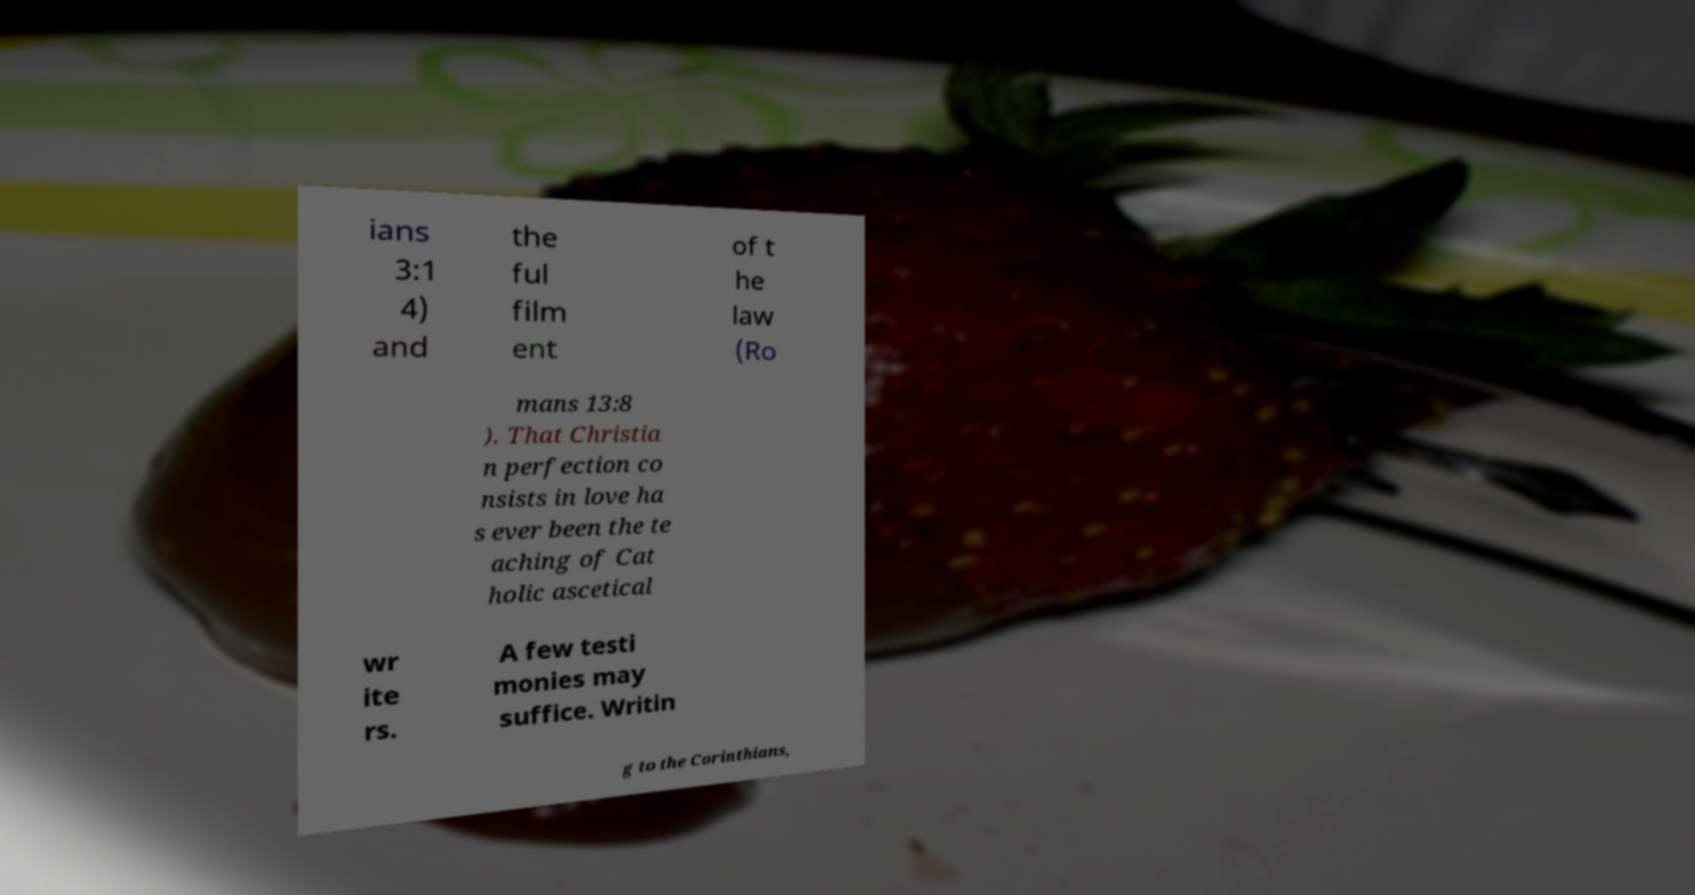Can you accurately transcribe the text from the provided image for me? ians 3:1 4) and the ful film ent of t he law (Ro mans 13:8 ). That Christia n perfection co nsists in love ha s ever been the te aching of Cat holic ascetical wr ite rs. A few testi monies may suffice. Writin g to the Corinthians, 